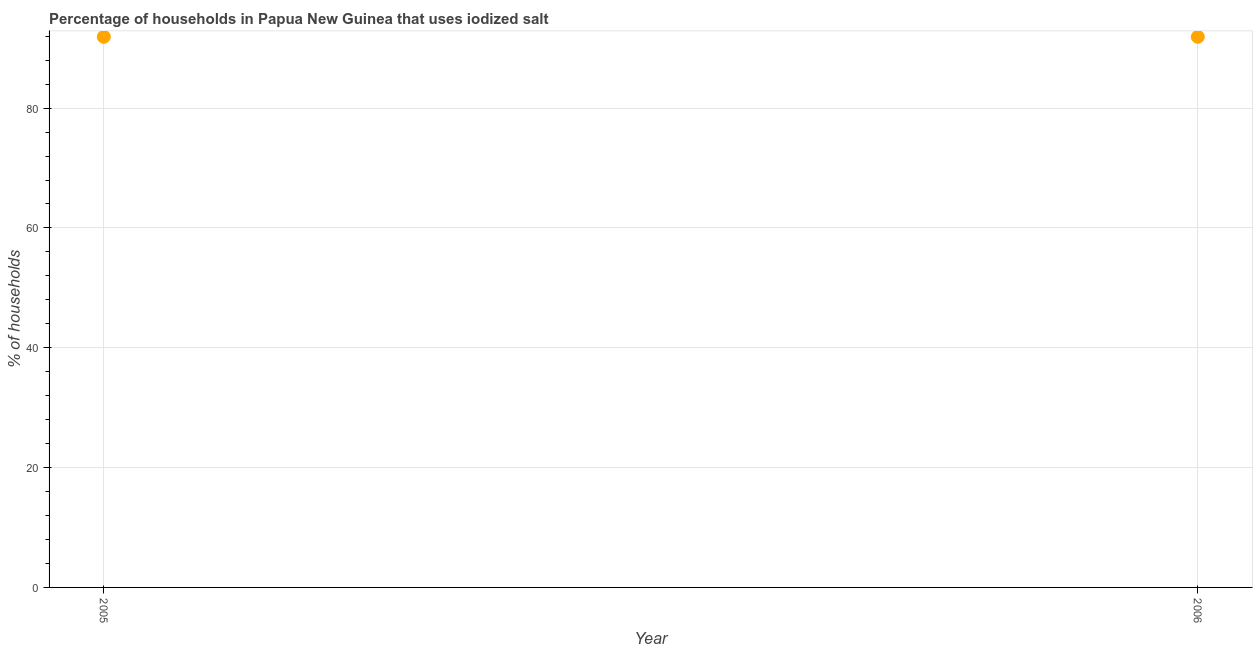What is the percentage of households where iodized salt is consumed in 2006?
Ensure brevity in your answer.  91.9. Across all years, what is the maximum percentage of households where iodized salt is consumed?
Make the answer very short. 91.9. Across all years, what is the minimum percentage of households where iodized salt is consumed?
Your answer should be very brief. 91.9. In which year was the percentage of households where iodized salt is consumed maximum?
Provide a short and direct response. 2005. In which year was the percentage of households where iodized salt is consumed minimum?
Your response must be concise. 2005. What is the sum of the percentage of households where iodized salt is consumed?
Offer a very short reply. 183.8. What is the difference between the percentage of households where iodized salt is consumed in 2005 and 2006?
Give a very brief answer. 0. What is the average percentage of households where iodized salt is consumed per year?
Keep it short and to the point. 91.9. What is the median percentage of households where iodized salt is consumed?
Provide a short and direct response. 91.9. In how many years, is the percentage of households where iodized salt is consumed greater than 72 %?
Keep it short and to the point. 2. Do a majority of the years between 2005 and 2006 (inclusive) have percentage of households where iodized salt is consumed greater than 4 %?
Your answer should be compact. Yes. How many dotlines are there?
Provide a succinct answer. 1. How many years are there in the graph?
Make the answer very short. 2. What is the difference between two consecutive major ticks on the Y-axis?
Offer a terse response. 20. Does the graph contain any zero values?
Your response must be concise. No. Does the graph contain grids?
Your response must be concise. Yes. What is the title of the graph?
Make the answer very short. Percentage of households in Papua New Guinea that uses iodized salt. What is the label or title of the Y-axis?
Make the answer very short. % of households. What is the % of households in 2005?
Keep it short and to the point. 91.9. What is the % of households in 2006?
Offer a terse response. 91.9. What is the difference between the % of households in 2005 and 2006?
Give a very brief answer. 0. What is the ratio of the % of households in 2005 to that in 2006?
Your answer should be very brief. 1. 